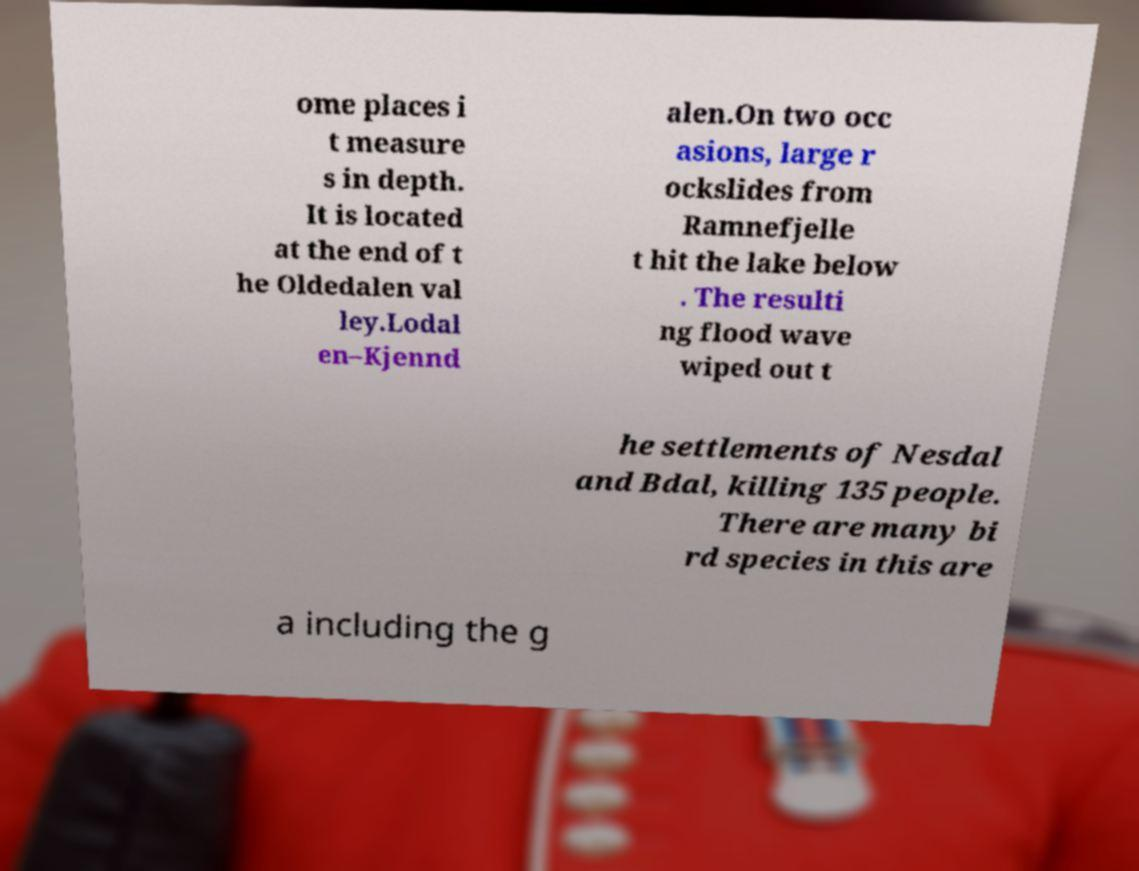There's text embedded in this image that I need extracted. Can you transcribe it verbatim? ome places i t measure s in depth. It is located at the end of t he Oldedalen val ley.Lodal en–Kjennd alen.On two occ asions, large r ockslides from Ramnefjelle t hit the lake below . The resulti ng flood wave wiped out t he settlements of Nesdal and Bdal, killing 135 people. There are many bi rd species in this are a including the g 